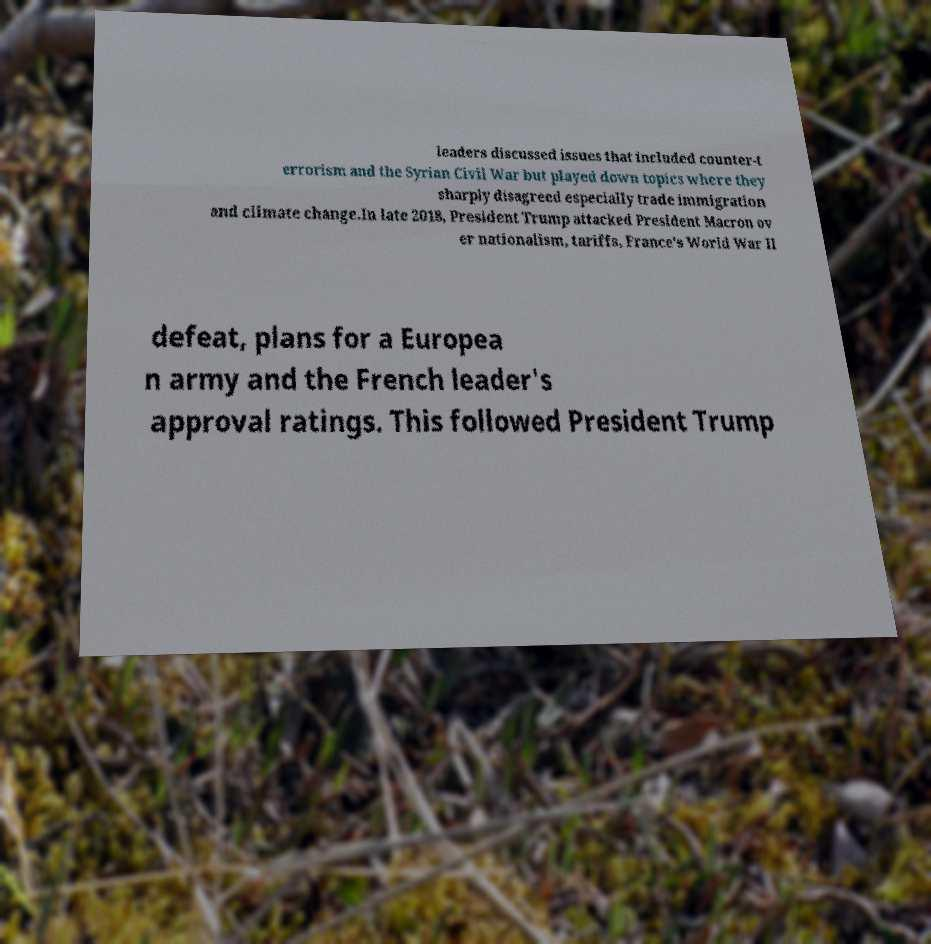Could you assist in decoding the text presented in this image and type it out clearly? leaders discussed issues that included counter-t errorism and the Syrian Civil War but played down topics where they sharply disagreed especially trade immigration and climate change.In late 2018, President Trump attacked President Macron ov er nationalism, tariffs, France's World War II defeat, plans for a Europea n army and the French leader's approval ratings. This followed President Trump 